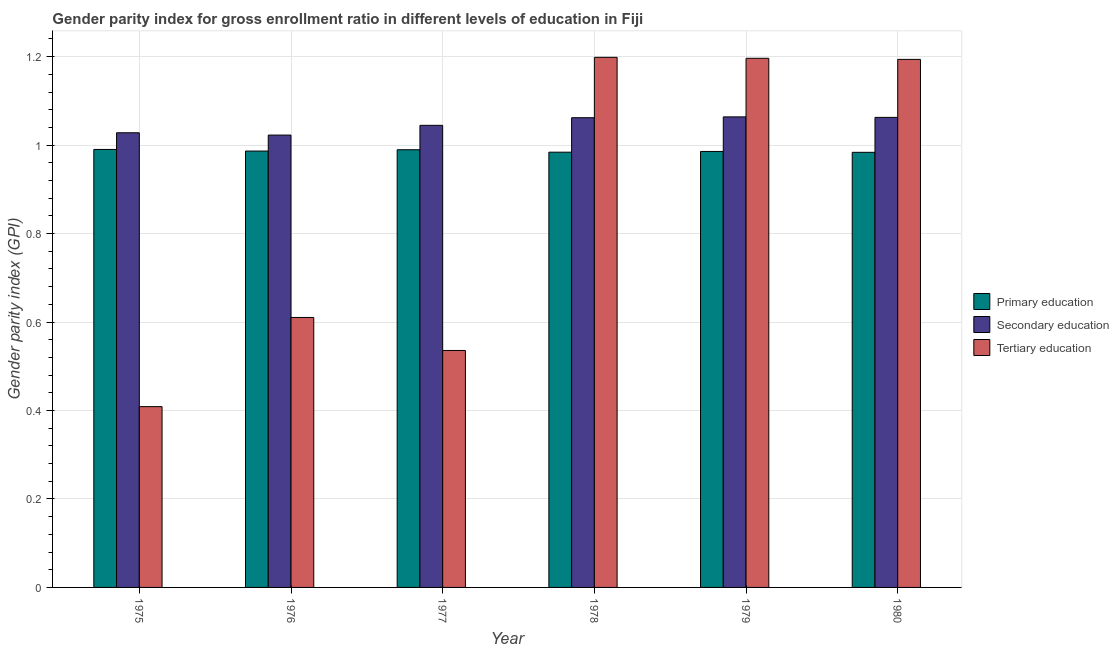How many bars are there on the 1st tick from the left?
Give a very brief answer. 3. What is the label of the 2nd group of bars from the left?
Your answer should be compact. 1976. What is the gender parity index in primary education in 1976?
Ensure brevity in your answer.  0.99. Across all years, what is the maximum gender parity index in tertiary education?
Keep it short and to the point. 1.2. Across all years, what is the minimum gender parity index in primary education?
Your answer should be compact. 0.98. In which year was the gender parity index in tertiary education maximum?
Give a very brief answer. 1978. In which year was the gender parity index in tertiary education minimum?
Your response must be concise. 1975. What is the total gender parity index in primary education in the graph?
Provide a succinct answer. 5.92. What is the difference between the gender parity index in secondary education in 1977 and that in 1978?
Keep it short and to the point. -0.02. What is the difference between the gender parity index in primary education in 1980 and the gender parity index in tertiary education in 1976?
Provide a short and direct response. -0. What is the average gender parity index in secondary education per year?
Your answer should be very brief. 1.05. In the year 1976, what is the difference between the gender parity index in tertiary education and gender parity index in primary education?
Provide a short and direct response. 0. What is the ratio of the gender parity index in secondary education in 1978 to that in 1979?
Ensure brevity in your answer.  1. Is the gender parity index in secondary education in 1975 less than that in 1979?
Offer a terse response. Yes. Is the difference between the gender parity index in primary education in 1979 and 1980 greater than the difference between the gender parity index in secondary education in 1979 and 1980?
Make the answer very short. No. What is the difference between the highest and the second highest gender parity index in tertiary education?
Provide a succinct answer. 0. What is the difference between the highest and the lowest gender parity index in secondary education?
Provide a succinct answer. 0.04. Is the sum of the gender parity index in secondary education in 1976 and 1977 greater than the maximum gender parity index in tertiary education across all years?
Provide a short and direct response. Yes. What does the 2nd bar from the left in 1975 represents?
Ensure brevity in your answer.  Secondary education. What does the 2nd bar from the right in 1980 represents?
Keep it short and to the point. Secondary education. What is the difference between two consecutive major ticks on the Y-axis?
Make the answer very short. 0.2. Are the values on the major ticks of Y-axis written in scientific E-notation?
Offer a very short reply. No. How many legend labels are there?
Give a very brief answer. 3. How are the legend labels stacked?
Keep it short and to the point. Vertical. What is the title of the graph?
Your response must be concise. Gender parity index for gross enrollment ratio in different levels of education in Fiji. What is the label or title of the Y-axis?
Provide a short and direct response. Gender parity index (GPI). What is the Gender parity index (GPI) in Primary education in 1975?
Offer a terse response. 0.99. What is the Gender parity index (GPI) in Secondary education in 1975?
Your answer should be very brief. 1.03. What is the Gender parity index (GPI) in Tertiary education in 1975?
Provide a short and direct response. 0.41. What is the Gender parity index (GPI) in Primary education in 1976?
Offer a terse response. 0.99. What is the Gender parity index (GPI) of Secondary education in 1976?
Give a very brief answer. 1.02. What is the Gender parity index (GPI) in Tertiary education in 1976?
Give a very brief answer. 0.61. What is the Gender parity index (GPI) in Primary education in 1977?
Your answer should be compact. 0.99. What is the Gender parity index (GPI) in Secondary education in 1977?
Provide a short and direct response. 1.04. What is the Gender parity index (GPI) of Tertiary education in 1977?
Give a very brief answer. 0.54. What is the Gender parity index (GPI) of Primary education in 1978?
Keep it short and to the point. 0.98. What is the Gender parity index (GPI) in Secondary education in 1978?
Ensure brevity in your answer.  1.06. What is the Gender parity index (GPI) of Tertiary education in 1978?
Offer a very short reply. 1.2. What is the Gender parity index (GPI) in Primary education in 1979?
Offer a very short reply. 0.99. What is the Gender parity index (GPI) in Secondary education in 1979?
Make the answer very short. 1.06. What is the Gender parity index (GPI) in Tertiary education in 1979?
Provide a succinct answer. 1.2. What is the Gender parity index (GPI) of Primary education in 1980?
Your response must be concise. 0.98. What is the Gender parity index (GPI) of Secondary education in 1980?
Make the answer very short. 1.06. What is the Gender parity index (GPI) of Tertiary education in 1980?
Give a very brief answer. 1.19. Across all years, what is the maximum Gender parity index (GPI) of Primary education?
Give a very brief answer. 0.99. Across all years, what is the maximum Gender parity index (GPI) of Secondary education?
Your answer should be very brief. 1.06. Across all years, what is the maximum Gender parity index (GPI) of Tertiary education?
Offer a terse response. 1.2. Across all years, what is the minimum Gender parity index (GPI) in Primary education?
Keep it short and to the point. 0.98. Across all years, what is the minimum Gender parity index (GPI) in Secondary education?
Your answer should be very brief. 1.02. Across all years, what is the minimum Gender parity index (GPI) of Tertiary education?
Provide a short and direct response. 0.41. What is the total Gender parity index (GPI) of Primary education in the graph?
Your response must be concise. 5.92. What is the total Gender parity index (GPI) in Secondary education in the graph?
Give a very brief answer. 6.28. What is the total Gender parity index (GPI) of Tertiary education in the graph?
Make the answer very short. 5.14. What is the difference between the Gender parity index (GPI) in Primary education in 1975 and that in 1976?
Make the answer very short. 0. What is the difference between the Gender parity index (GPI) in Secondary education in 1975 and that in 1976?
Offer a terse response. 0.01. What is the difference between the Gender parity index (GPI) in Tertiary education in 1975 and that in 1976?
Give a very brief answer. -0.2. What is the difference between the Gender parity index (GPI) in Primary education in 1975 and that in 1977?
Provide a succinct answer. 0. What is the difference between the Gender parity index (GPI) in Secondary education in 1975 and that in 1977?
Provide a succinct answer. -0.02. What is the difference between the Gender parity index (GPI) in Tertiary education in 1975 and that in 1977?
Your response must be concise. -0.13. What is the difference between the Gender parity index (GPI) of Primary education in 1975 and that in 1978?
Keep it short and to the point. 0.01. What is the difference between the Gender parity index (GPI) in Secondary education in 1975 and that in 1978?
Ensure brevity in your answer.  -0.03. What is the difference between the Gender parity index (GPI) in Tertiary education in 1975 and that in 1978?
Your response must be concise. -0.79. What is the difference between the Gender parity index (GPI) of Primary education in 1975 and that in 1979?
Provide a succinct answer. 0. What is the difference between the Gender parity index (GPI) of Secondary education in 1975 and that in 1979?
Provide a succinct answer. -0.04. What is the difference between the Gender parity index (GPI) in Tertiary education in 1975 and that in 1979?
Your answer should be very brief. -0.79. What is the difference between the Gender parity index (GPI) of Primary education in 1975 and that in 1980?
Offer a terse response. 0.01. What is the difference between the Gender parity index (GPI) of Secondary education in 1975 and that in 1980?
Make the answer very short. -0.03. What is the difference between the Gender parity index (GPI) in Tertiary education in 1975 and that in 1980?
Offer a terse response. -0.79. What is the difference between the Gender parity index (GPI) of Primary education in 1976 and that in 1977?
Your answer should be very brief. -0. What is the difference between the Gender parity index (GPI) of Secondary education in 1976 and that in 1977?
Ensure brevity in your answer.  -0.02. What is the difference between the Gender parity index (GPI) of Tertiary education in 1976 and that in 1977?
Your answer should be very brief. 0.07. What is the difference between the Gender parity index (GPI) in Primary education in 1976 and that in 1978?
Make the answer very short. 0. What is the difference between the Gender parity index (GPI) of Secondary education in 1976 and that in 1978?
Offer a very short reply. -0.04. What is the difference between the Gender parity index (GPI) in Tertiary education in 1976 and that in 1978?
Give a very brief answer. -0.59. What is the difference between the Gender parity index (GPI) in Primary education in 1976 and that in 1979?
Your answer should be compact. 0. What is the difference between the Gender parity index (GPI) in Secondary education in 1976 and that in 1979?
Offer a terse response. -0.04. What is the difference between the Gender parity index (GPI) of Tertiary education in 1976 and that in 1979?
Make the answer very short. -0.59. What is the difference between the Gender parity index (GPI) in Primary education in 1976 and that in 1980?
Give a very brief answer. 0. What is the difference between the Gender parity index (GPI) of Secondary education in 1976 and that in 1980?
Provide a short and direct response. -0.04. What is the difference between the Gender parity index (GPI) of Tertiary education in 1976 and that in 1980?
Give a very brief answer. -0.58. What is the difference between the Gender parity index (GPI) of Primary education in 1977 and that in 1978?
Your answer should be very brief. 0.01. What is the difference between the Gender parity index (GPI) in Secondary education in 1977 and that in 1978?
Your answer should be very brief. -0.02. What is the difference between the Gender parity index (GPI) of Tertiary education in 1977 and that in 1978?
Make the answer very short. -0.66. What is the difference between the Gender parity index (GPI) of Primary education in 1977 and that in 1979?
Give a very brief answer. 0. What is the difference between the Gender parity index (GPI) of Secondary education in 1977 and that in 1979?
Make the answer very short. -0.02. What is the difference between the Gender parity index (GPI) of Tertiary education in 1977 and that in 1979?
Your response must be concise. -0.66. What is the difference between the Gender parity index (GPI) in Primary education in 1977 and that in 1980?
Give a very brief answer. 0.01. What is the difference between the Gender parity index (GPI) in Secondary education in 1977 and that in 1980?
Offer a terse response. -0.02. What is the difference between the Gender parity index (GPI) of Tertiary education in 1977 and that in 1980?
Provide a short and direct response. -0.66. What is the difference between the Gender parity index (GPI) in Primary education in 1978 and that in 1979?
Give a very brief answer. -0. What is the difference between the Gender parity index (GPI) of Secondary education in 1978 and that in 1979?
Your answer should be very brief. -0. What is the difference between the Gender parity index (GPI) in Tertiary education in 1978 and that in 1979?
Give a very brief answer. 0. What is the difference between the Gender parity index (GPI) of Secondary education in 1978 and that in 1980?
Give a very brief answer. -0. What is the difference between the Gender parity index (GPI) in Tertiary education in 1978 and that in 1980?
Provide a succinct answer. 0. What is the difference between the Gender parity index (GPI) in Primary education in 1979 and that in 1980?
Your response must be concise. 0. What is the difference between the Gender parity index (GPI) in Secondary education in 1979 and that in 1980?
Your answer should be compact. 0. What is the difference between the Gender parity index (GPI) in Tertiary education in 1979 and that in 1980?
Make the answer very short. 0. What is the difference between the Gender parity index (GPI) of Primary education in 1975 and the Gender parity index (GPI) of Secondary education in 1976?
Keep it short and to the point. -0.03. What is the difference between the Gender parity index (GPI) of Primary education in 1975 and the Gender parity index (GPI) of Tertiary education in 1976?
Provide a succinct answer. 0.38. What is the difference between the Gender parity index (GPI) of Secondary education in 1975 and the Gender parity index (GPI) of Tertiary education in 1976?
Give a very brief answer. 0.42. What is the difference between the Gender parity index (GPI) in Primary education in 1975 and the Gender parity index (GPI) in Secondary education in 1977?
Provide a succinct answer. -0.05. What is the difference between the Gender parity index (GPI) of Primary education in 1975 and the Gender parity index (GPI) of Tertiary education in 1977?
Keep it short and to the point. 0.45. What is the difference between the Gender parity index (GPI) of Secondary education in 1975 and the Gender parity index (GPI) of Tertiary education in 1977?
Provide a short and direct response. 0.49. What is the difference between the Gender parity index (GPI) in Primary education in 1975 and the Gender parity index (GPI) in Secondary education in 1978?
Offer a terse response. -0.07. What is the difference between the Gender parity index (GPI) of Primary education in 1975 and the Gender parity index (GPI) of Tertiary education in 1978?
Your response must be concise. -0.21. What is the difference between the Gender parity index (GPI) of Secondary education in 1975 and the Gender parity index (GPI) of Tertiary education in 1978?
Give a very brief answer. -0.17. What is the difference between the Gender parity index (GPI) of Primary education in 1975 and the Gender parity index (GPI) of Secondary education in 1979?
Your response must be concise. -0.07. What is the difference between the Gender parity index (GPI) of Primary education in 1975 and the Gender parity index (GPI) of Tertiary education in 1979?
Make the answer very short. -0.21. What is the difference between the Gender parity index (GPI) of Secondary education in 1975 and the Gender parity index (GPI) of Tertiary education in 1979?
Offer a terse response. -0.17. What is the difference between the Gender parity index (GPI) of Primary education in 1975 and the Gender parity index (GPI) of Secondary education in 1980?
Ensure brevity in your answer.  -0.07. What is the difference between the Gender parity index (GPI) in Primary education in 1975 and the Gender parity index (GPI) in Tertiary education in 1980?
Keep it short and to the point. -0.2. What is the difference between the Gender parity index (GPI) of Secondary education in 1975 and the Gender parity index (GPI) of Tertiary education in 1980?
Your response must be concise. -0.17. What is the difference between the Gender parity index (GPI) of Primary education in 1976 and the Gender parity index (GPI) of Secondary education in 1977?
Keep it short and to the point. -0.06. What is the difference between the Gender parity index (GPI) in Primary education in 1976 and the Gender parity index (GPI) in Tertiary education in 1977?
Provide a short and direct response. 0.45. What is the difference between the Gender parity index (GPI) in Secondary education in 1976 and the Gender parity index (GPI) in Tertiary education in 1977?
Your answer should be compact. 0.49. What is the difference between the Gender parity index (GPI) of Primary education in 1976 and the Gender parity index (GPI) of Secondary education in 1978?
Your answer should be very brief. -0.08. What is the difference between the Gender parity index (GPI) of Primary education in 1976 and the Gender parity index (GPI) of Tertiary education in 1978?
Your response must be concise. -0.21. What is the difference between the Gender parity index (GPI) of Secondary education in 1976 and the Gender parity index (GPI) of Tertiary education in 1978?
Provide a short and direct response. -0.18. What is the difference between the Gender parity index (GPI) in Primary education in 1976 and the Gender parity index (GPI) in Secondary education in 1979?
Offer a very short reply. -0.08. What is the difference between the Gender parity index (GPI) in Primary education in 1976 and the Gender parity index (GPI) in Tertiary education in 1979?
Keep it short and to the point. -0.21. What is the difference between the Gender parity index (GPI) of Secondary education in 1976 and the Gender parity index (GPI) of Tertiary education in 1979?
Make the answer very short. -0.17. What is the difference between the Gender parity index (GPI) of Primary education in 1976 and the Gender parity index (GPI) of Secondary education in 1980?
Your response must be concise. -0.08. What is the difference between the Gender parity index (GPI) of Primary education in 1976 and the Gender parity index (GPI) of Tertiary education in 1980?
Provide a short and direct response. -0.21. What is the difference between the Gender parity index (GPI) of Secondary education in 1976 and the Gender parity index (GPI) of Tertiary education in 1980?
Your answer should be very brief. -0.17. What is the difference between the Gender parity index (GPI) of Primary education in 1977 and the Gender parity index (GPI) of Secondary education in 1978?
Make the answer very short. -0.07. What is the difference between the Gender parity index (GPI) of Primary education in 1977 and the Gender parity index (GPI) of Tertiary education in 1978?
Keep it short and to the point. -0.21. What is the difference between the Gender parity index (GPI) of Secondary education in 1977 and the Gender parity index (GPI) of Tertiary education in 1978?
Your answer should be compact. -0.15. What is the difference between the Gender parity index (GPI) in Primary education in 1977 and the Gender parity index (GPI) in Secondary education in 1979?
Keep it short and to the point. -0.07. What is the difference between the Gender parity index (GPI) in Primary education in 1977 and the Gender parity index (GPI) in Tertiary education in 1979?
Your response must be concise. -0.21. What is the difference between the Gender parity index (GPI) of Secondary education in 1977 and the Gender parity index (GPI) of Tertiary education in 1979?
Make the answer very short. -0.15. What is the difference between the Gender parity index (GPI) of Primary education in 1977 and the Gender parity index (GPI) of Secondary education in 1980?
Offer a terse response. -0.07. What is the difference between the Gender parity index (GPI) in Primary education in 1977 and the Gender parity index (GPI) in Tertiary education in 1980?
Your answer should be very brief. -0.2. What is the difference between the Gender parity index (GPI) of Secondary education in 1977 and the Gender parity index (GPI) of Tertiary education in 1980?
Provide a succinct answer. -0.15. What is the difference between the Gender parity index (GPI) in Primary education in 1978 and the Gender parity index (GPI) in Secondary education in 1979?
Your answer should be compact. -0.08. What is the difference between the Gender parity index (GPI) of Primary education in 1978 and the Gender parity index (GPI) of Tertiary education in 1979?
Offer a terse response. -0.21. What is the difference between the Gender parity index (GPI) in Secondary education in 1978 and the Gender parity index (GPI) in Tertiary education in 1979?
Give a very brief answer. -0.13. What is the difference between the Gender parity index (GPI) of Primary education in 1978 and the Gender parity index (GPI) of Secondary education in 1980?
Offer a terse response. -0.08. What is the difference between the Gender parity index (GPI) in Primary education in 1978 and the Gender parity index (GPI) in Tertiary education in 1980?
Make the answer very short. -0.21. What is the difference between the Gender parity index (GPI) in Secondary education in 1978 and the Gender parity index (GPI) in Tertiary education in 1980?
Make the answer very short. -0.13. What is the difference between the Gender parity index (GPI) in Primary education in 1979 and the Gender parity index (GPI) in Secondary education in 1980?
Offer a terse response. -0.08. What is the difference between the Gender parity index (GPI) in Primary education in 1979 and the Gender parity index (GPI) in Tertiary education in 1980?
Give a very brief answer. -0.21. What is the difference between the Gender parity index (GPI) of Secondary education in 1979 and the Gender parity index (GPI) of Tertiary education in 1980?
Keep it short and to the point. -0.13. What is the average Gender parity index (GPI) in Primary education per year?
Offer a very short reply. 0.99. What is the average Gender parity index (GPI) of Secondary education per year?
Your answer should be compact. 1.05. What is the average Gender parity index (GPI) of Tertiary education per year?
Your response must be concise. 0.86. In the year 1975, what is the difference between the Gender parity index (GPI) in Primary education and Gender parity index (GPI) in Secondary education?
Offer a very short reply. -0.04. In the year 1975, what is the difference between the Gender parity index (GPI) of Primary education and Gender parity index (GPI) of Tertiary education?
Make the answer very short. 0.58. In the year 1975, what is the difference between the Gender parity index (GPI) in Secondary education and Gender parity index (GPI) in Tertiary education?
Your answer should be very brief. 0.62. In the year 1976, what is the difference between the Gender parity index (GPI) in Primary education and Gender parity index (GPI) in Secondary education?
Ensure brevity in your answer.  -0.04. In the year 1976, what is the difference between the Gender parity index (GPI) of Primary education and Gender parity index (GPI) of Tertiary education?
Offer a very short reply. 0.38. In the year 1976, what is the difference between the Gender parity index (GPI) in Secondary education and Gender parity index (GPI) in Tertiary education?
Offer a very short reply. 0.41. In the year 1977, what is the difference between the Gender parity index (GPI) in Primary education and Gender parity index (GPI) in Secondary education?
Your response must be concise. -0.06. In the year 1977, what is the difference between the Gender parity index (GPI) in Primary education and Gender parity index (GPI) in Tertiary education?
Your answer should be compact. 0.45. In the year 1977, what is the difference between the Gender parity index (GPI) of Secondary education and Gender parity index (GPI) of Tertiary education?
Ensure brevity in your answer.  0.51. In the year 1978, what is the difference between the Gender parity index (GPI) of Primary education and Gender parity index (GPI) of Secondary education?
Ensure brevity in your answer.  -0.08. In the year 1978, what is the difference between the Gender parity index (GPI) of Primary education and Gender parity index (GPI) of Tertiary education?
Your response must be concise. -0.21. In the year 1978, what is the difference between the Gender parity index (GPI) in Secondary education and Gender parity index (GPI) in Tertiary education?
Your answer should be very brief. -0.14. In the year 1979, what is the difference between the Gender parity index (GPI) in Primary education and Gender parity index (GPI) in Secondary education?
Make the answer very short. -0.08. In the year 1979, what is the difference between the Gender parity index (GPI) in Primary education and Gender parity index (GPI) in Tertiary education?
Offer a very short reply. -0.21. In the year 1979, what is the difference between the Gender parity index (GPI) in Secondary education and Gender parity index (GPI) in Tertiary education?
Give a very brief answer. -0.13. In the year 1980, what is the difference between the Gender parity index (GPI) of Primary education and Gender parity index (GPI) of Secondary education?
Ensure brevity in your answer.  -0.08. In the year 1980, what is the difference between the Gender parity index (GPI) of Primary education and Gender parity index (GPI) of Tertiary education?
Provide a short and direct response. -0.21. In the year 1980, what is the difference between the Gender parity index (GPI) in Secondary education and Gender parity index (GPI) in Tertiary education?
Your answer should be very brief. -0.13. What is the ratio of the Gender parity index (GPI) of Primary education in 1975 to that in 1976?
Make the answer very short. 1. What is the ratio of the Gender parity index (GPI) of Tertiary education in 1975 to that in 1976?
Make the answer very short. 0.67. What is the ratio of the Gender parity index (GPI) of Secondary education in 1975 to that in 1977?
Ensure brevity in your answer.  0.98. What is the ratio of the Gender parity index (GPI) of Tertiary education in 1975 to that in 1977?
Your answer should be compact. 0.76. What is the ratio of the Gender parity index (GPI) of Secondary education in 1975 to that in 1978?
Make the answer very short. 0.97. What is the ratio of the Gender parity index (GPI) in Tertiary education in 1975 to that in 1978?
Your response must be concise. 0.34. What is the ratio of the Gender parity index (GPI) of Secondary education in 1975 to that in 1979?
Ensure brevity in your answer.  0.97. What is the ratio of the Gender parity index (GPI) in Tertiary education in 1975 to that in 1979?
Your answer should be compact. 0.34. What is the ratio of the Gender parity index (GPI) in Primary education in 1975 to that in 1980?
Offer a terse response. 1.01. What is the ratio of the Gender parity index (GPI) of Secondary education in 1975 to that in 1980?
Give a very brief answer. 0.97. What is the ratio of the Gender parity index (GPI) in Tertiary education in 1975 to that in 1980?
Make the answer very short. 0.34. What is the ratio of the Gender parity index (GPI) in Secondary education in 1976 to that in 1977?
Provide a short and direct response. 0.98. What is the ratio of the Gender parity index (GPI) of Tertiary education in 1976 to that in 1977?
Your response must be concise. 1.14. What is the ratio of the Gender parity index (GPI) in Secondary education in 1976 to that in 1978?
Ensure brevity in your answer.  0.96. What is the ratio of the Gender parity index (GPI) in Tertiary education in 1976 to that in 1978?
Your answer should be compact. 0.51. What is the ratio of the Gender parity index (GPI) in Secondary education in 1976 to that in 1979?
Offer a very short reply. 0.96. What is the ratio of the Gender parity index (GPI) of Tertiary education in 1976 to that in 1979?
Provide a succinct answer. 0.51. What is the ratio of the Gender parity index (GPI) of Primary education in 1976 to that in 1980?
Keep it short and to the point. 1. What is the ratio of the Gender parity index (GPI) of Secondary education in 1976 to that in 1980?
Provide a succinct answer. 0.96. What is the ratio of the Gender parity index (GPI) in Tertiary education in 1976 to that in 1980?
Your response must be concise. 0.51. What is the ratio of the Gender parity index (GPI) of Primary education in 1977 to that in 1978?
Give a very brief answer. 1.01. What is the ratio of the Gender parity index (GPI) in Secondary education in 1977 to that in 1978?
Ensure brevity in your answer.  0.98. What is the ratio of the Gender parity index (GPI) in Tertiary education in 1977 to that in 1978?
Provide a short and direct response. 0.45. What is the ratio of the Gender parity index (GPI) in Tertiary education in 1977 to that in 1979?
Your answer should be very brief. 0.45. What is the ratio of the Gender parity index (GPI) of Primary education in 1977 to that in 1980?
Make the answer very short. 1.01. What is the ratio of the Gender parity index (GPI) in Secondary education in 1977 to that in 1980?
Ensure brevity in your answer.  0.98. What is the ratio of the Gender parity index (GPI) of Tertiary education in 1977 to that in 1980?
Give a very brief answer. 0.45. What is the ratio of the Gender parity index (GPI) of Tertiary education in 1978 to that in 1980?
Your answer should be compact. 1. What is the ratio of the Gender parity index (GPI) in Primary education in 1979 to that in 1980?
Offer a very short reply. 1. What is the difference between the highest and the second highest Gender parity index (GPI) in Primary education?
Your response must be concise. 0. What is the difference between the highest and the second highest Gender parity index (GPI) in Secondary education?
Give a very brief answer. 0. What is the difference between the highest and the second highest Gender parity index (GPI) of Tertiary education?
Ensure brevity in your answer.  0. What is the difference between the highest and the lowest Gender parity index (GPI) in Primary education?
Provide a short and direct response. 0.01. What is the difference between the highest and the lowest Gender parity index (GPI) of Secondary education?
Provide a short and direct response. 0.04. What is the difference between the highest and the lowest Gender parity index (GPI) of Tertiary education?
Provide a short and direct response. 0.79. 